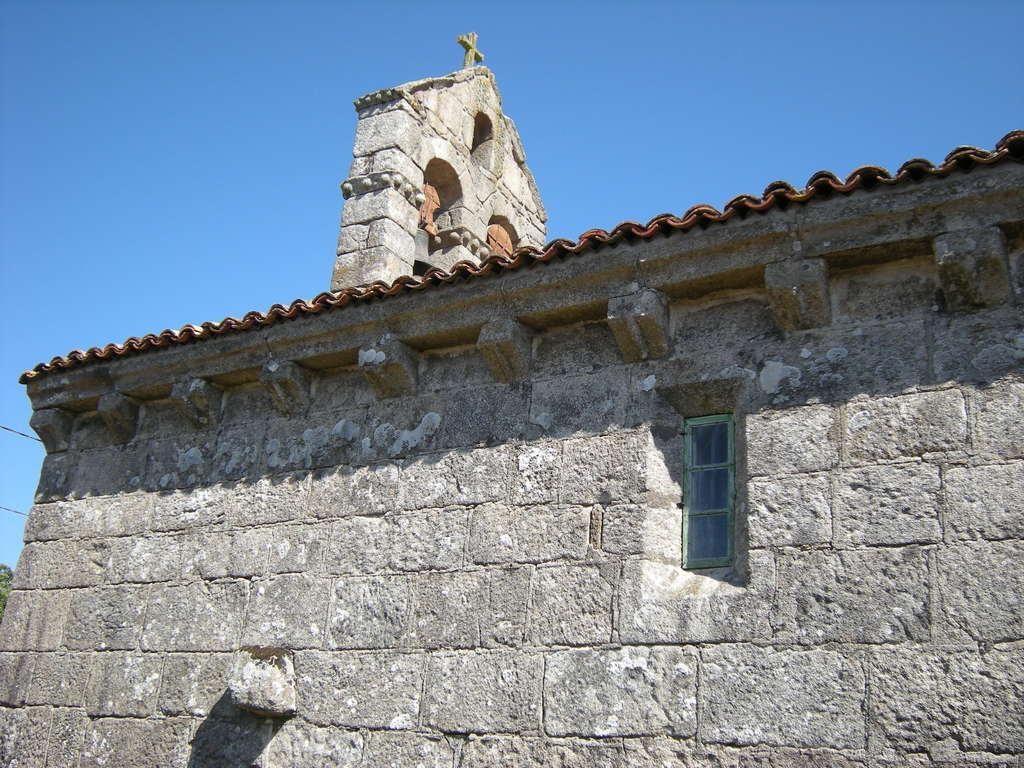What type of structure is in the image? There is a building in the image. What material is used for the wall of the building? The building has a brick wall. Are there any openings in the building? Yes, there is a window in the building. What is located at the top of the building? There is a cross at the top of the building. What can be seen in the background of the image? The sky is visible in the background of the image. Where are the toys placed in the image? There are no toys present in the image. Is there a sink visible in the image? There is no sink present in the image. 